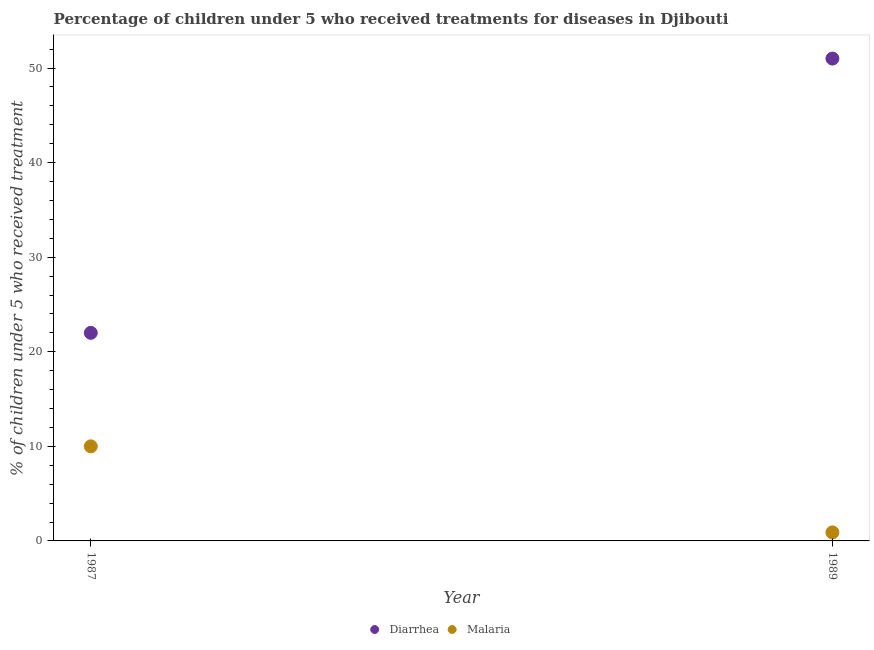How many different coloured dotlines are there?
Your answer should be compact. 2. What is the percentage of children who received treatment for diarrhoea in 1989?
Offer a terse response. 51. Across all years, what is the maximum percentage of children who received treatment for diarrhoea?
Ensure brevity in your answer.  51. Across all years, what is the minimum percentage of children who received treatment for diarrhoea?
Give a very brief answer. 22. In which year was the percentage of children who received treatment for diarrhoea maximum?
Provide a succinct answer. 1989. In which year was the percentage of children who received treatment for malaria minimum?
Keep it short and to the point. 1989. What is the total percentage of children who received treatment for malaria in the graph?
Ensure brevity in your answer.  10.9. What is the difference between the percentage of children who received treatment for diarrhoea in 1987 and that in 1989?
Your answer should be compact. -29. What is the difference between the percentage of children who received treatment for diarrhoea in 1989 and the percentage of children who received treatment for malaria in 1987?
Your answer should be very brief. 41. What is the average percentage of children who received treatment for diarrhoea per year?
Your answer should be compact. 36.5. In the year 1989, what is the difference between the percentage of children who received treatment for malaria and percentage of children who received treatment for diarrhoea?
Offer a very short reply. -50.1. In how many years, is the percentage of children who received treatment for diarrhoea greater than 28 %?
Offer a very short reply. 1. What is the ratio of the percentage of children who received treatment for diarrhoea in 1987 to that in 1989?
Ensure brevity in your answer.  0.43. Does the percentage of children who received treatment for diarrhoea monotonically increase over the years?
Your answer should be very brief. Yes. Is the percentage of children who received treatment for diarrhoea strictly greater than the percentage of children who received treatment for malaria over the years?
Offer a very short reply. Yes. How many years are there in the graph?
Provide a short and direct response. 2. What is the difference between two consecutive major ticks on the Y-axis?
Keep it short and to the point. 10. Does the graph contain grids?
Keep it short and to the point. No. How are the legend labels stacked?
Give a very brief answer. Horizontal. What is the title of the graph?
Keep it short and to the point. Percentage of children under 5 who received treatments for diseases in Djibouti. What is the label or title of the X-axis?
Provide a succinct answer. Year. What is the label or title of the Y-axis?
Offer a very short reply. % of children under 5 who received treatment. Across all years, what is the maximum % of children under 5 who received treatment of Diarrhea?
Your response must be concise. 51. Across all years, what is the maximum % of children under 5 who received treatment of Malaria?
Offer a terse response. 10. What is the total % of children under 5 who received treatment in Diarrhea in the graph?
Make the answer very short. 73. What is the total % of children under 5 who received treatment of Malaria in the graph?
Provide a short and direct response. 10.9. What is the difference between the % of children under 5 who received treatment of Diarrhea in 1987 and that in 1989?
Keep it short and to the point. -29. What is the difference between the % of children under 5 who received treatment of Malaria in 1987 and that in 1989?
Keep it short and to the point. 9.1. What is the difference between the % of children under 5 who received treatment of Diarrhea in 1987 and the % of children under 5 who received treatment of Malaria in 1989?
Offer a very short reply. 21.1. What is the average % of children under 5 who received treatment in Diarrhea per year?
Your response must be concise. 36.5. What is the average % of children under 5 who received treatment in Malaria per year?
Give a very brief answer. 5.45. In the year 1989, what is the difference between the % of children under 5 who received treatment of Diarrhea and % of children under 5 who received treatment of Malaria?
Offer a very short reply. 50.1. What is the ratio of the % of children under 5 who received treatment in Diarrhea in 1987 to that in 1989?
Make the answer very short. 0.43. What is the ratio of the % of children under 5 who received treatment of Malaria in 1987 to that in 1989?
Provide a succinct answer. 11.11. What is the difference between the highest and the second highest % of children under 5 who received treatment of Diarrhea?
Make the answer very short. 29. What is the difference between the highest and the lowest % of children under 5 who received treatment in Malaria?
Offer a very short reply. 9.1. 